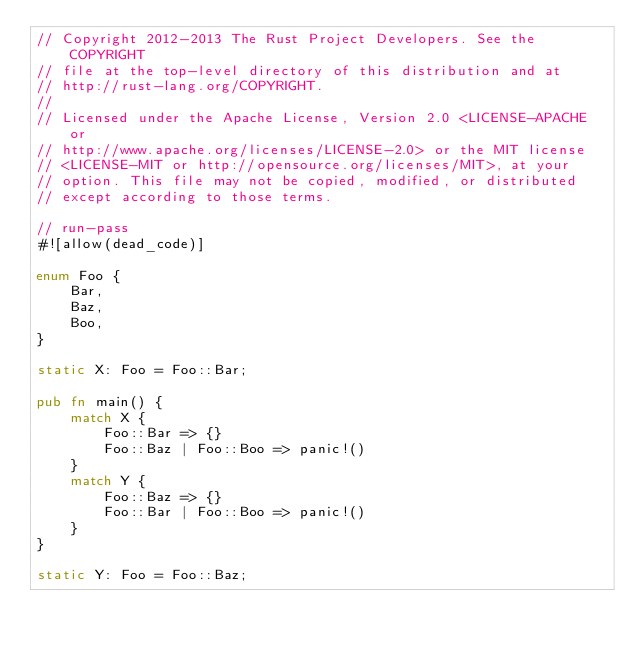Convert code to text. <code><loc_0><loc_0><loc_500><loc_500><_Rust_>// Copyright 2012-2013 The Rust Project Developers. See the COPYRIGHT
// file at the top-level directory of this distribution and at
// http://rust-lang.org/COPYRIGHT.
//
// Licensed under the Apache License, Version 2.0 <LICENSE-APACHE or
// http://www.apache.org/licenses/LICENSE-2.0> or the MIT license
// <LICENSE-MIT or http://opensource.org/licenses/MIT>, at your
// option. This file may not be copied, modified, or distributed
// except according to those terms.

// run-pass
#![allow(dead_code)]

enum Foo {
    Bar,
    Baz,
    Boo,
}

static X: Foo = Foo::Bar;

pub fn main() {
    match X {
        Foo::Bar => {}
        Foo::Baz | Foo::Boo => panic!()
    }
    match Y {
        Foo::Baz => {}
        Foo::Bar | Foo::Boo => panic!()
    }
}

static Y: Foo = Foo::Baz;
</code> 